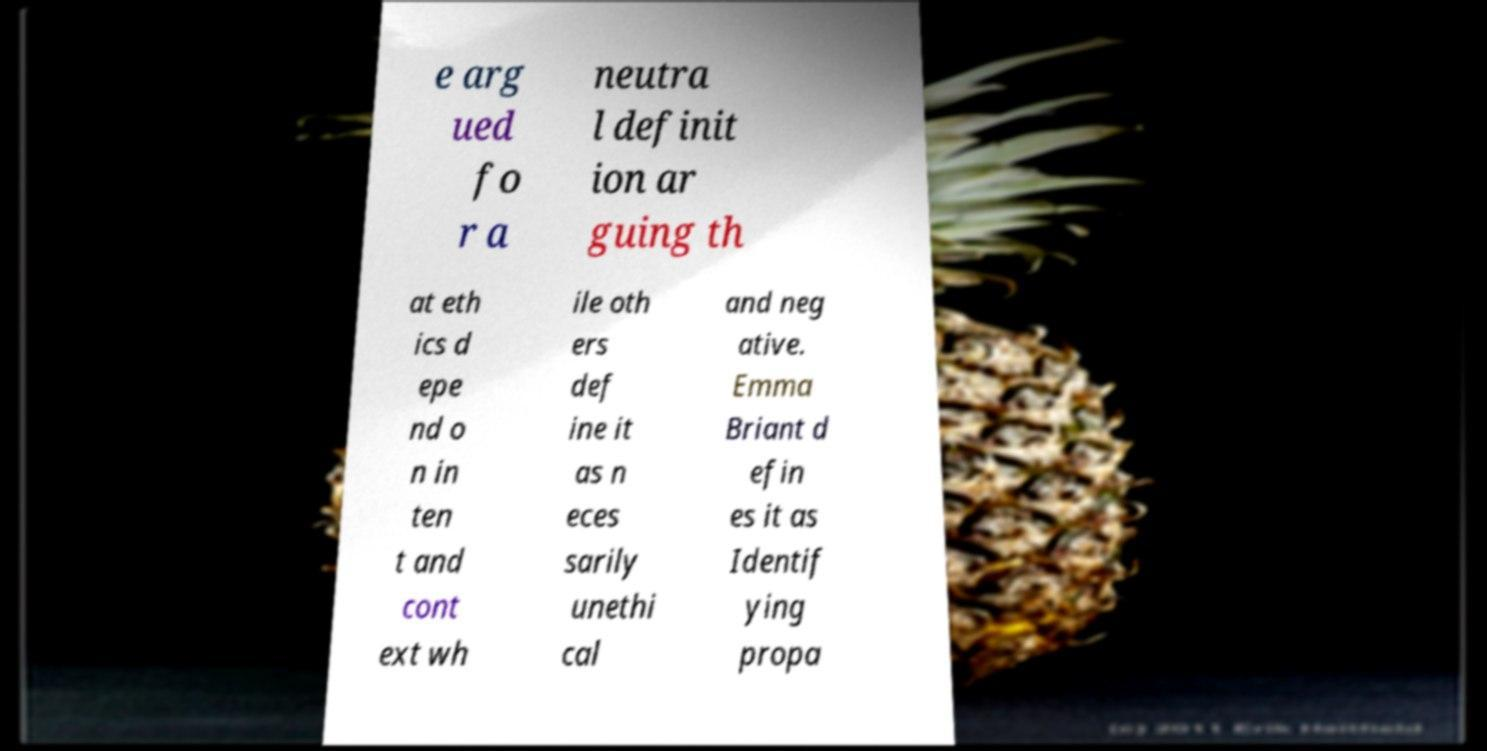Could you extract and type out the text from this image? e arg ued fo r a neutra l definit ion ar guing th at eth ics d epe nd o n in ten t and cont ext wh ile oth ers def ine it as n eces sarily unethi cal and neg ative. Emma Briant d efin es it as Identif ying propa 